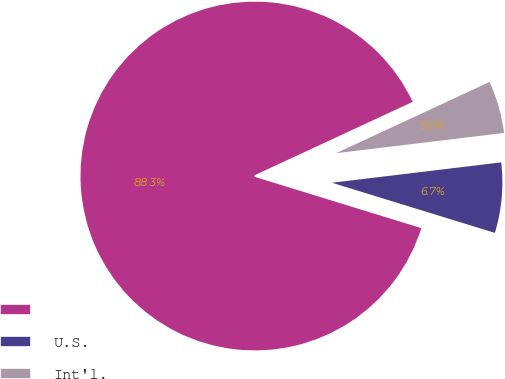Convert chart. <chart><loc_0><loc_0><loc_500><loc_500><pie_chart><ecel><fcel>U.S.<fcel>Int'l.<nl><fcel>88.33%<fcel>6.66%<fcel>5.01%<nl></chart> 